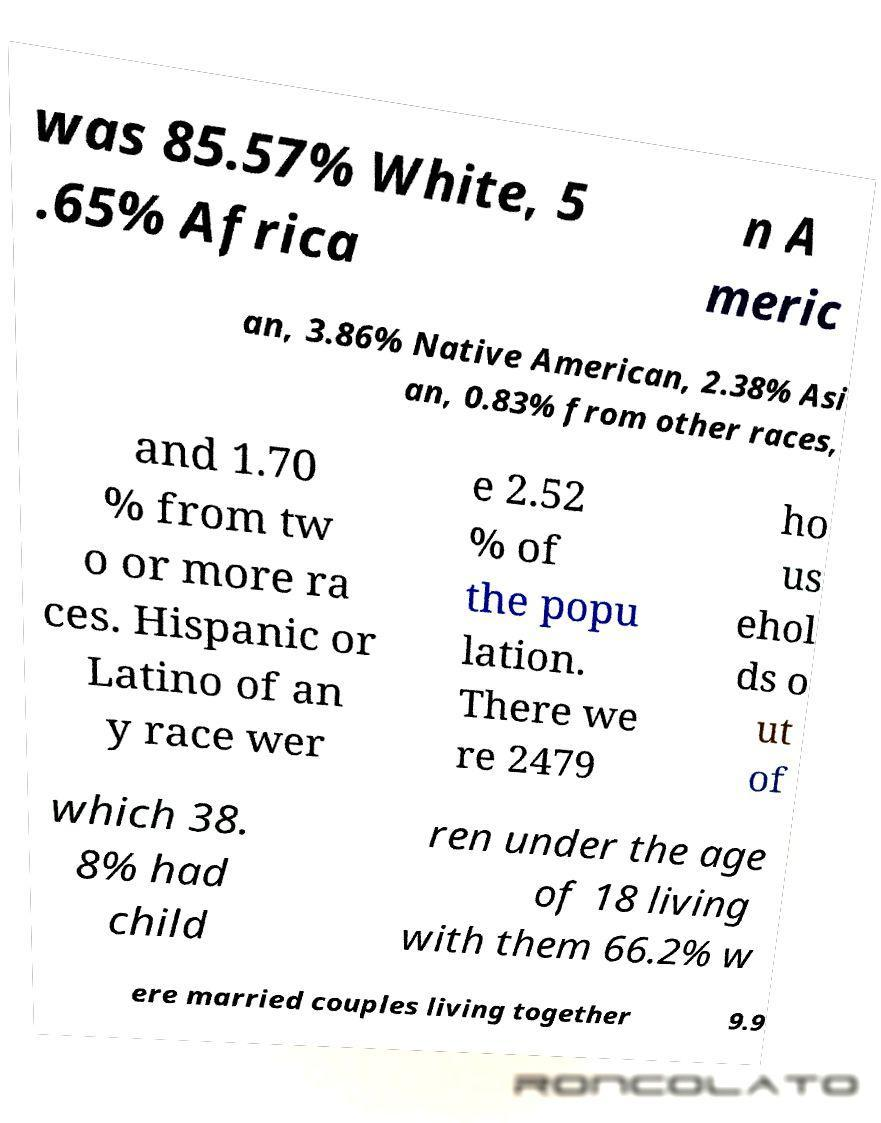Could you assist in decoding the text presented in this image and type it out clearly? was 85.57% White, 5 .65% Africa n A meric an, 3.86% Native American, 2.38% Asi an, 0.83% from other races, and 1.70 % from tw o or more ra ces. Hispanic or Latino of an y race wer e 2.52 % of the popu lation. There we re 2479 ho us ehol ds o ut of which 38. 8% had child ren under the age of 18 living with them 66.2% w ere married couples living together 9.9 